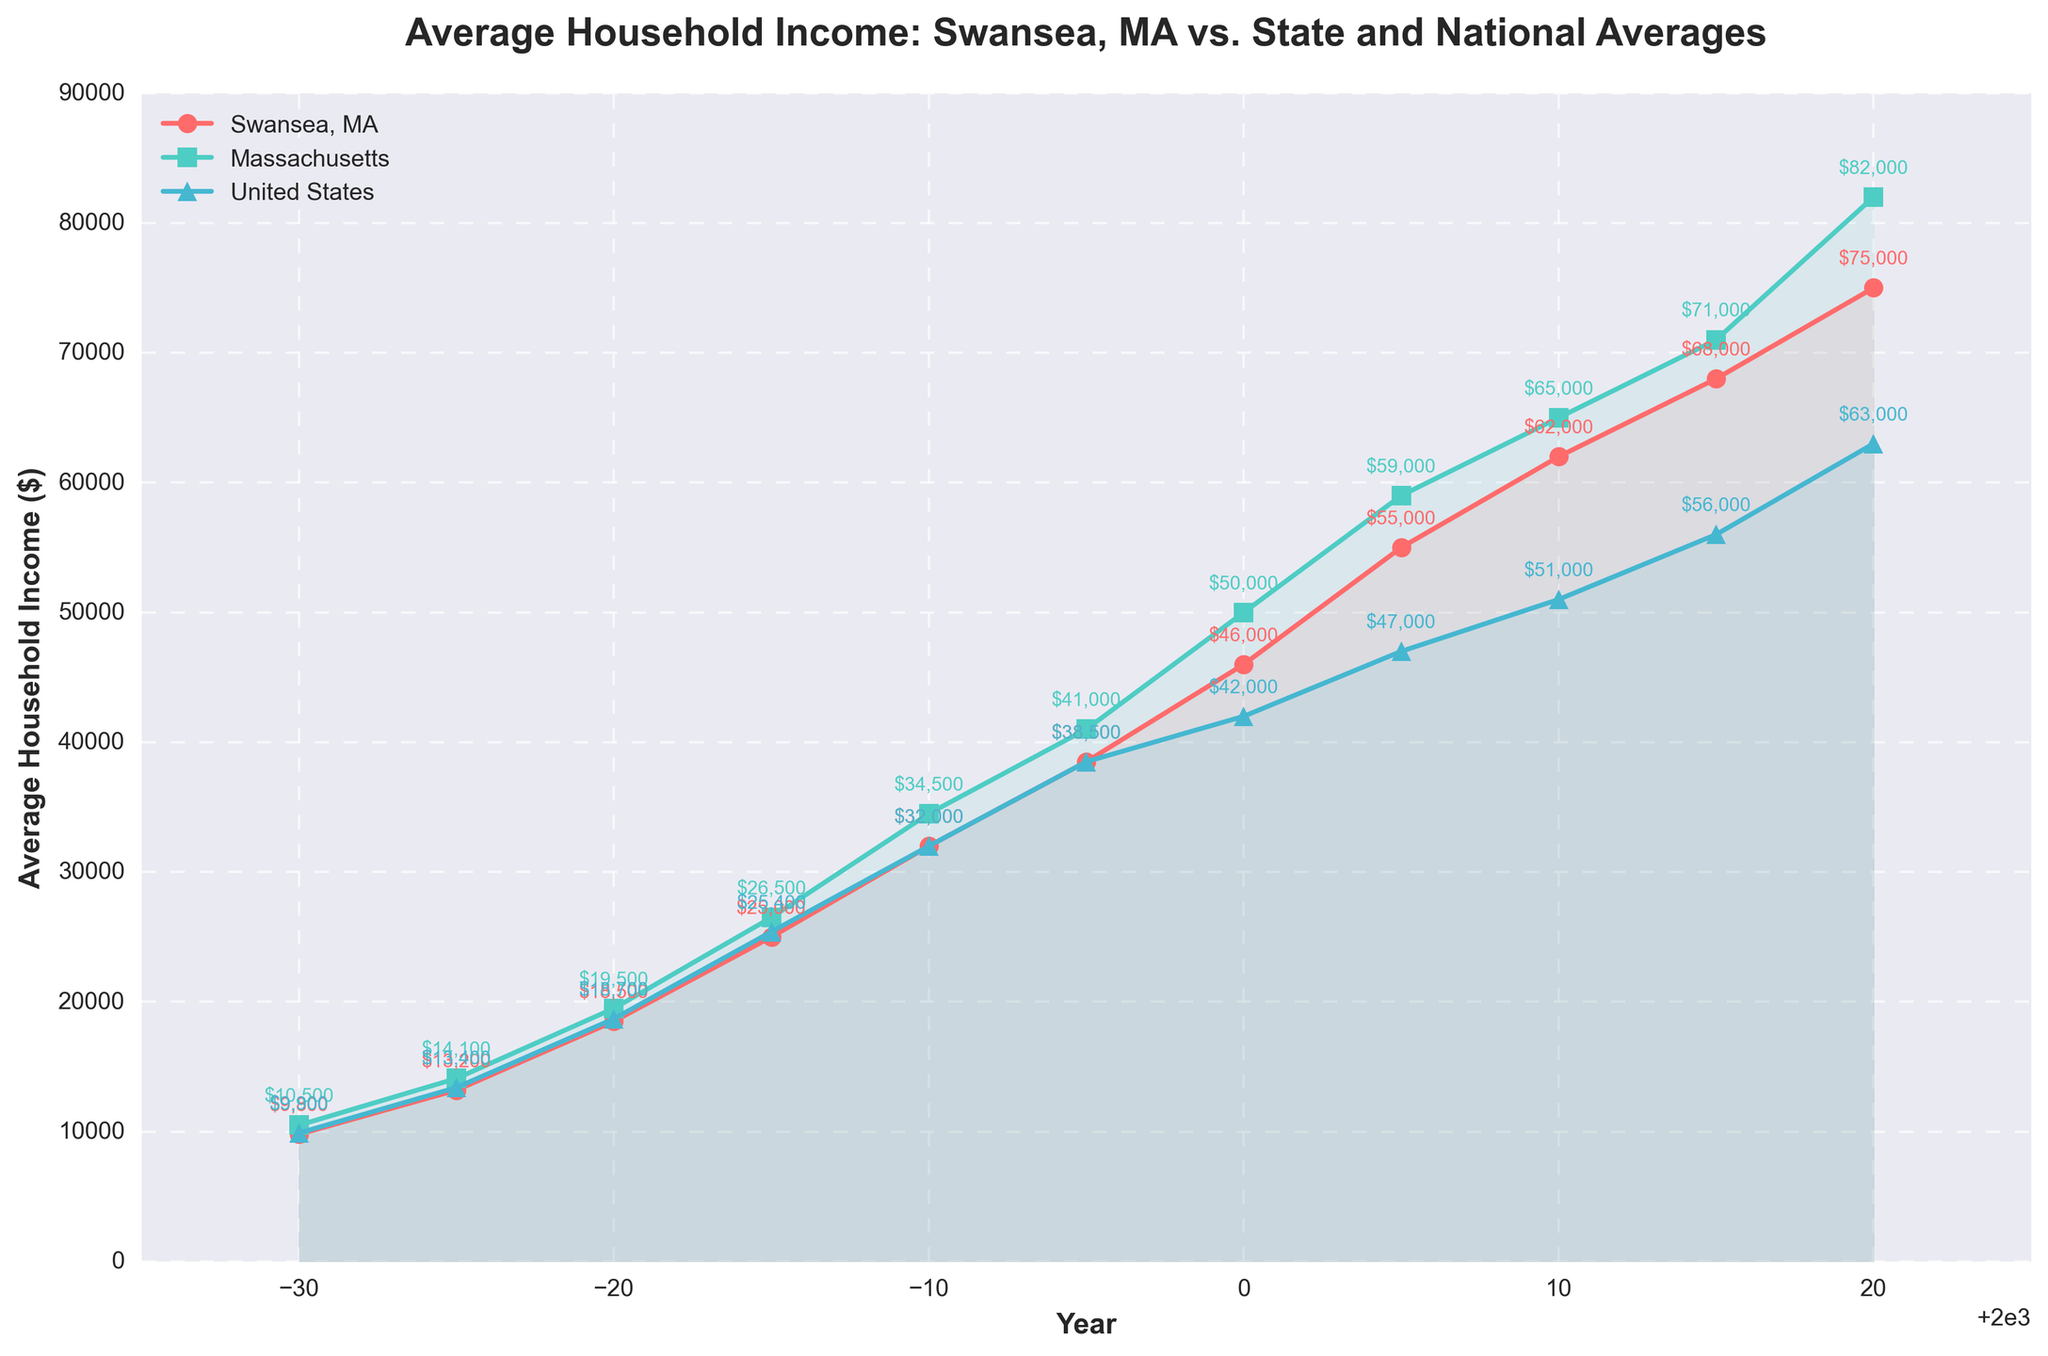What is the average household income in 2020 for Swansea, MA? Locate the data points for the year 2020 on the graph and check the value of Swansea, MA, which is annotated.
Answer: $75,000 In which year did the average household income for Swansea, MA surpass the national average? Look at the line representing Swansea, MA and the United States, and identify the year when the Swansea, MA line crosses above the United States line. This occurs between 1975 to 1980.
Answer: 1980 By how much did the average household income in Massachusetts exceed the national average in 2020? Find the 2020 data points for Massachusetts and the United States, which are annotated. Calculate the difference between them: $82,000 - $63,000.
Answer: $19,000 In which year did Swansea, MA have the least difference in average household income compared to the national average? Calculate the differences between Swansea, MA and the United States for each year, and find the year with the smallest difference. From the data, 1970 has the least difference: $9,800 - $9,900 = -$100.
Answer: 1970 How much did the average household income increase in Swansea, MA from 1970 to 2020? Subtract the 1970 value from the 2020 value for Swansea, MA: $75,000 - $9,800.
Answer: $65,200 Which region had the highest growth rate in average household income between 1970 and 2020? Calculate the growth rates for each region by finding the percentage increase from 1970 to 2020. Compare Massachusetts ($82,000 - $10,500/$10,500), Swansea ($75,000 - $9,800/$9,800), and US ($63,000 - $9,900/$9,900). Massachusetts has the highest growth rate.
Answer: Massachusetts Which year shows the largest gap between Swansea, MA and Massachusetts average household incomes? Identify the years and calculate the differences between Swansea, MA and Massachusetts for all years. The year with the largest difference is 2020: $82,000 - $75,000 = $7,000.
Answer: 2020 Describe the trend in the average household income for Swansea, MA from 1970 to 2020. Observe the line representing Swansea, MA from 1970 to 2020. It shows a consistent upward trend with steady increases over each period.
Answer: Consistent upward trend What is the visual difference between the lines representing Swansea, MA, Massachusetts, and the United States in terms of style and color? The Swansea, MA line is red with circle markers, the Massachusetts line is green with square markers, and the United States line is blue with triangle markers.
Answer: Red with circles, green with squares, blue with triangles How does the average household income in Massachusetts in 1995 compare to the average household income in the United States in 2000? Locate and compare the 1995 Massachusetts data point ($41,000) with the 2000 United States data point ($42,000).
Answer: Massachusetts in 1995 is slightly less 